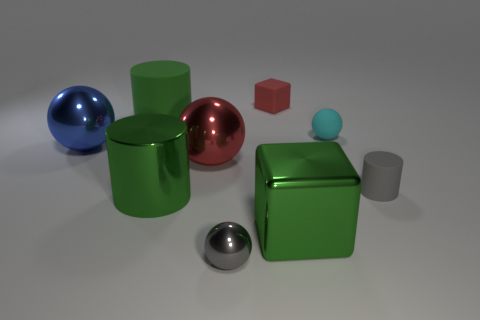How are the colors of the objects in the image distributed? The image features a variety of colors with the objects: there's a blue sphere, a green cylindrical can, a red cube, a light blue small sphere on top of a green cube, a small gray cylinder, and a metallic sphere. The colors are evenly distributed across the scene without clustering in one area, creating a harmonious balance. 